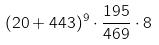<formula> <loc_0><loc_0><loc_500><loc_500>( 2 0 + 4 4 3 ) ^ { 9 } \cdot \frac { 1 9 5 } { 4 6 9 } \cdot 8</formula> 